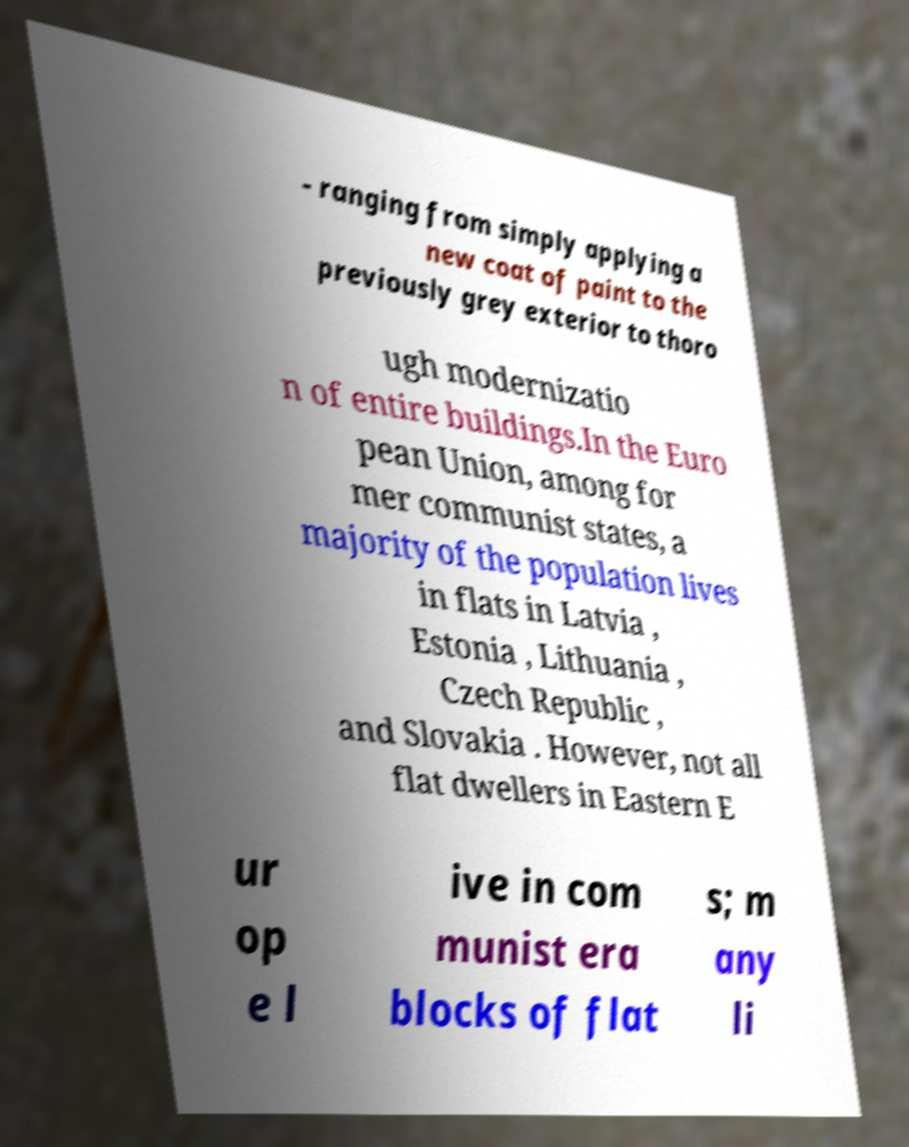Could you extract and type out the text from this image? - ranging from simply applying a new coat of paint to the previously grey exterior to thoro ugh modernizatio n of entire buildings.In the Euro pean Union, among for mer communist states, a majority of the population lives in flats in Latvia , Estonia , Lithuania , Czech Republic , and Slovakia . However, not all flat dwellers in Eastern E ur op e l ive in com munist era blocks of flat s; m any li 